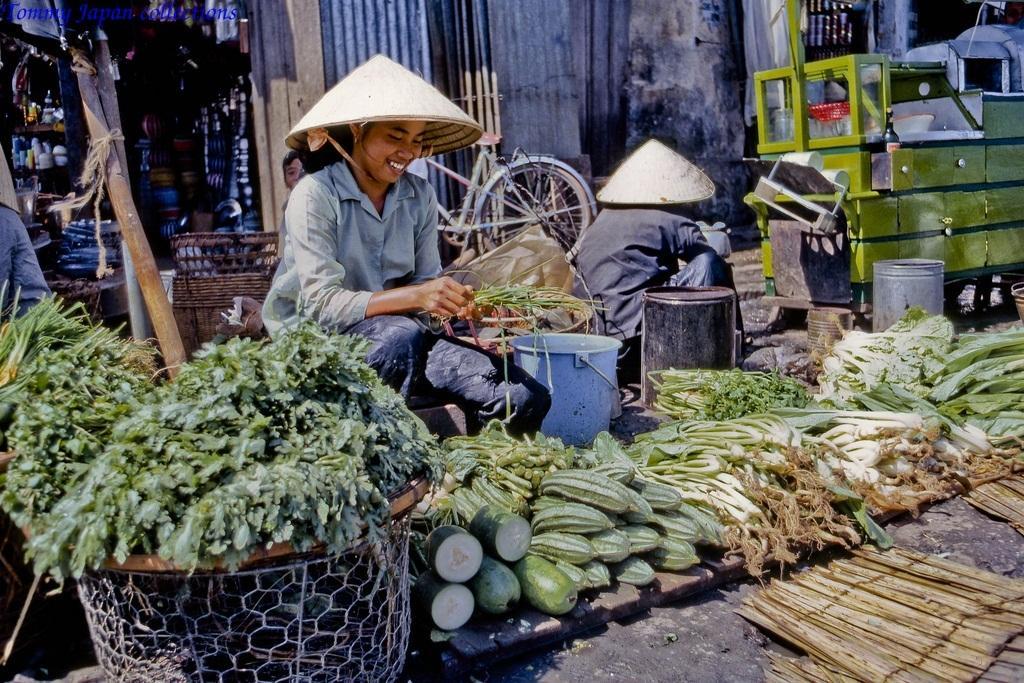How would you summarize this image in a sentence or two? In this image there are some persons sitting in middle of this image and there are some vegetables kept in the bottom of this image. There is one person on the left side of this image and there is a shop on the top left corner of this image. There is a wall in the background. There is a wooden shelf on the right side of this image. 